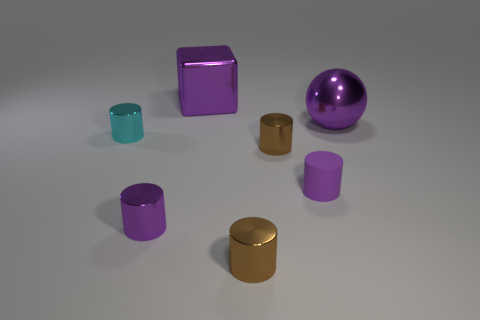What number of objects are big purple balls or brown cylinders?
Offer a very short reply. 3. Are there any large metallic spheres of the same color as the big shiny block?
Offer a very short reply. Yes. There is a purple cylinder on the right side of the purple shiny cube; what number of big spheres are in front of it?
Give a very brief answer. 0. Are there more yellow rubber things than rubber things?
Make the answer very short. No. Do the cube and the cyan cylinder have the same material?
Make the answer very short. Yes. Are there an equal number of tiny matte objects that are in front of the purple rubber thing and brown cylinders?
Provide a short and direct response. No. What number of brown things are the same material as the big purple cube?
Your answer should be very brief. 2. Are there fewer green rubber cylinders than tiny purple objects?
Your response must be concise. Yes. Does the large thing on the right side of the purple matte cylinder have the same color as the small matte object?
Give a very brief answer. Yes. There is a large purple metal object on the left side of the tiny brown metal cylinder in front of the rubber cylinder; how many purple rubber objects are to the left of it?
Your answer should be compact. 0. 